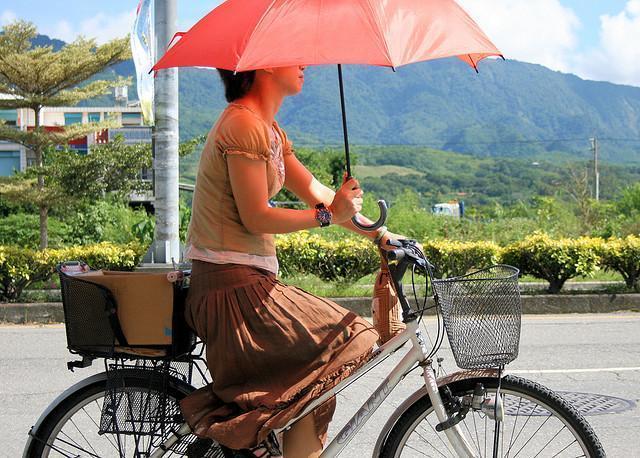How many trains are there?
Give a very brief answer. 0. 